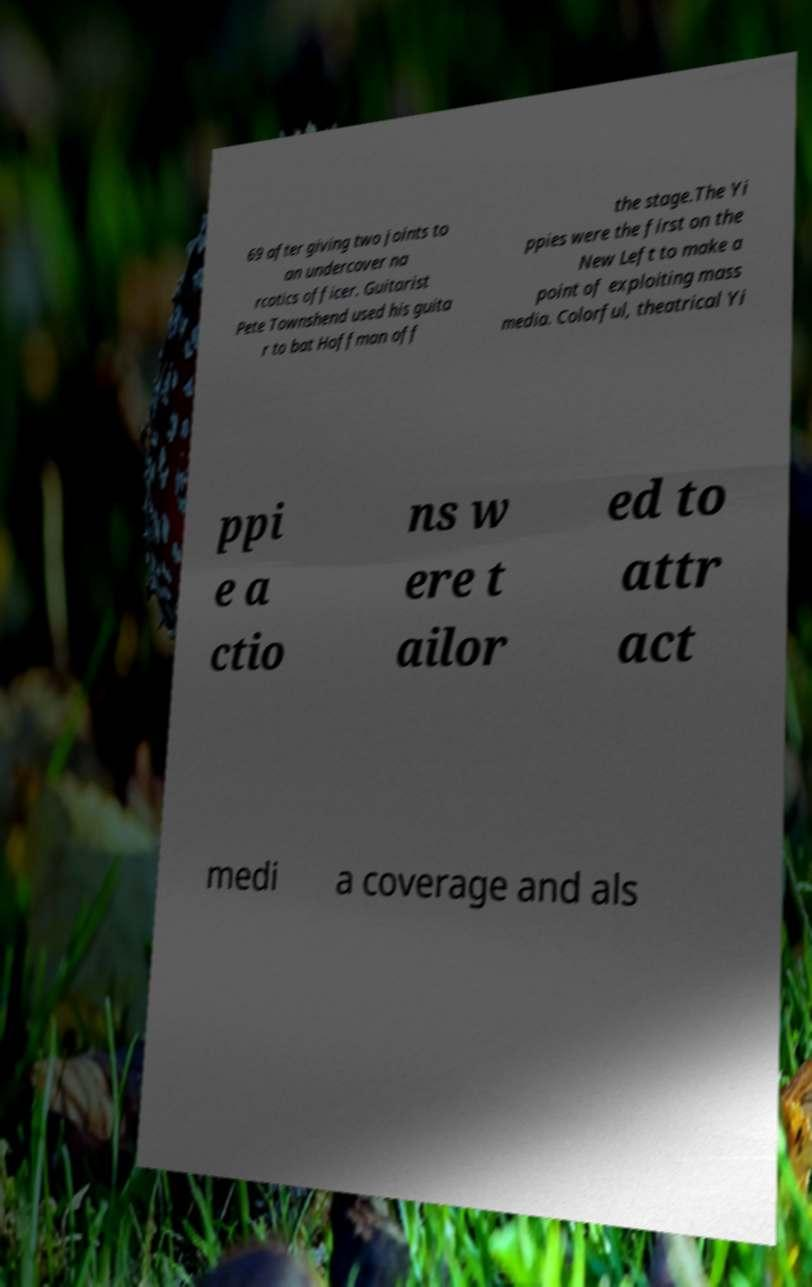There's text embedded in this image that I need extracted. Can you transcribe it verbatim? 69 after giving two joints to an undercover na rcotics officer. Guitarist Pete Townshend used his guita r to bat Hoffman off the stage.The Yi ppies were the first on the New Left to make a point of exploiting mass media. Colorful, theatrical Yi ppi e a ctio ns w ere t ailor ed to attr act medi a coverage and als 